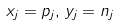Convert formula to latex. <formula><loc_0><loc_0><loc_500><loc_500>x _ { j } = p _ { j } , \, y _ { j } = n _ { j }</formula> 